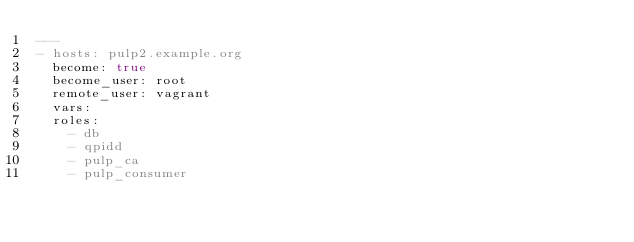<code> <loc_0><loc_0><loc_500><loc_500><_YAML_>---
- hosts: pulp2.example.org
  become: true
  become_user: root
  remote_user: vagrant
  vars:
  roles:
    - db
    - qpidd
    - pulp_ca
    - pulp_consumer
</code> 